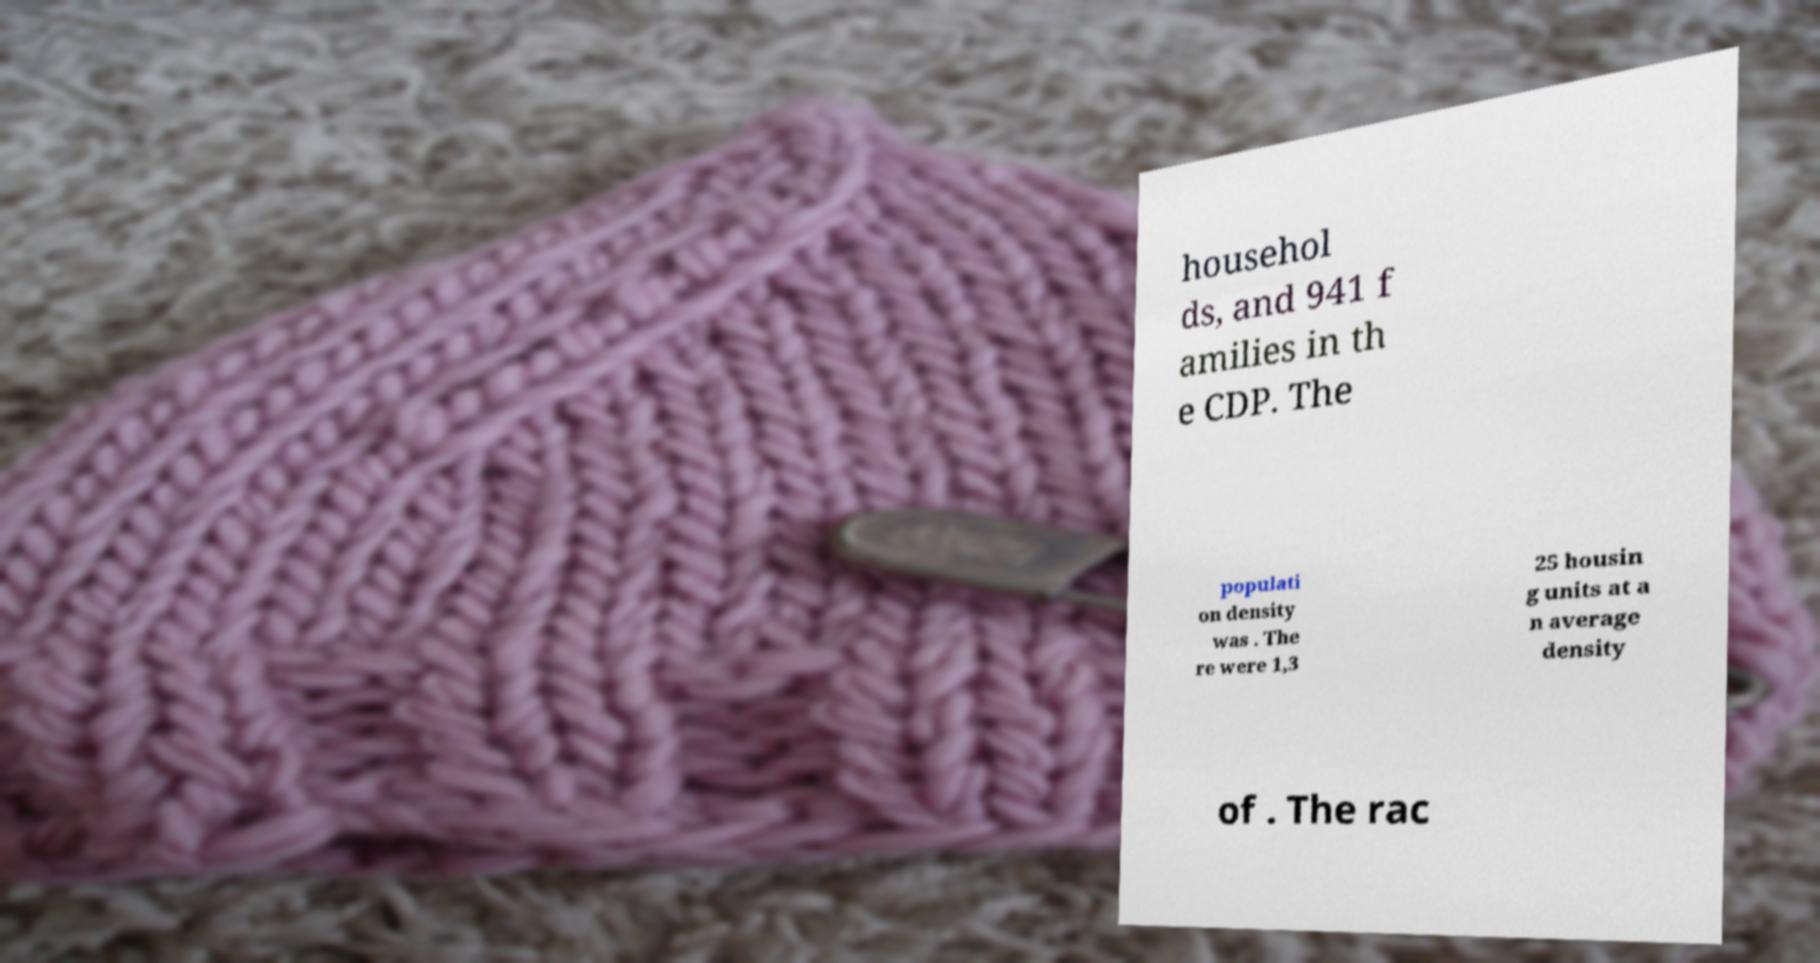Please read and relay the text visible in this image. What does it say? househol ds, and 941 f amilies in th e CDP. The populati on density was . The re were 1,3 25 housin g units at a n average density of . The rac 